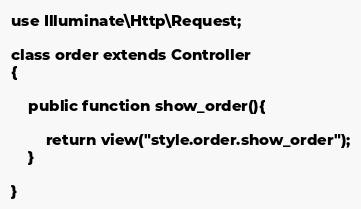Convert code to text. <code><loc_0><loc_0><loc_500><loc_500><_PHP_>use Illuminate\Http\Request;

class order extends Controller
{
 
    public function show_order(){

        return view("style.order.show_order");
    }
 
}
</code> 